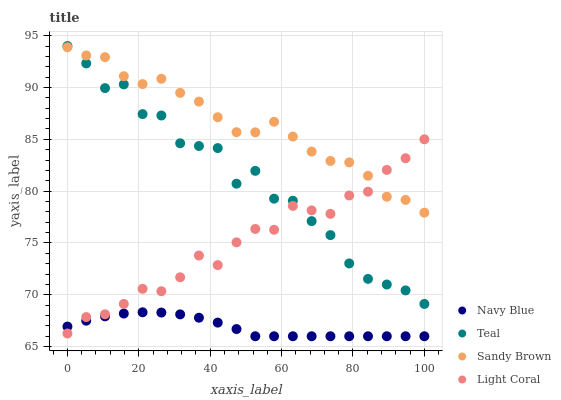Does Navy Blue have the minimum area under the curve?
Answer yes or no. Yes. Does Sandy Brown have the maximum area under the curve?
Answer yes or no. Yes. Does Sandy Brown have the minimum area under the curve?
Answer yes or no. No. Does Navy Blue have the maximum area under the curve?
Answer yes or no. No. Is Navy Blue the smoothest?
Answer yes or no. Yes. Is Teal the roughest?
Answer yes or no. Yes. Is Sandy Brown the smoothest?
Answer yes or no. No. Is Sandy Brown the roughest?
Answer yes or no. No. Does Navy Blue have the lowest value?
Answer yes or no. Yes. Does Sandy Brown have the lowest value?
Answer yes or no. No. Does Teal have the highest value?
Answer yes or no. Yes. Does Sandy Brown have the highest value?
Answer yes or no. No. Is Navy Blue less than Sandy Brown?
Answer yes or no. Yes. Is Sandy Brown greater than Navy Blue?
Answer yes or no. Yes. Does Sandy Brown intersect Teal?
Answer yes or no. Yes. Is Sandy Brown less than Teal?
Answer yes or no. No. Is Sandy Brown greater than Teal?
Answer yes or no. No. Does Navy Blue intersect Sandy Brown?
Answer yes or no. No. 